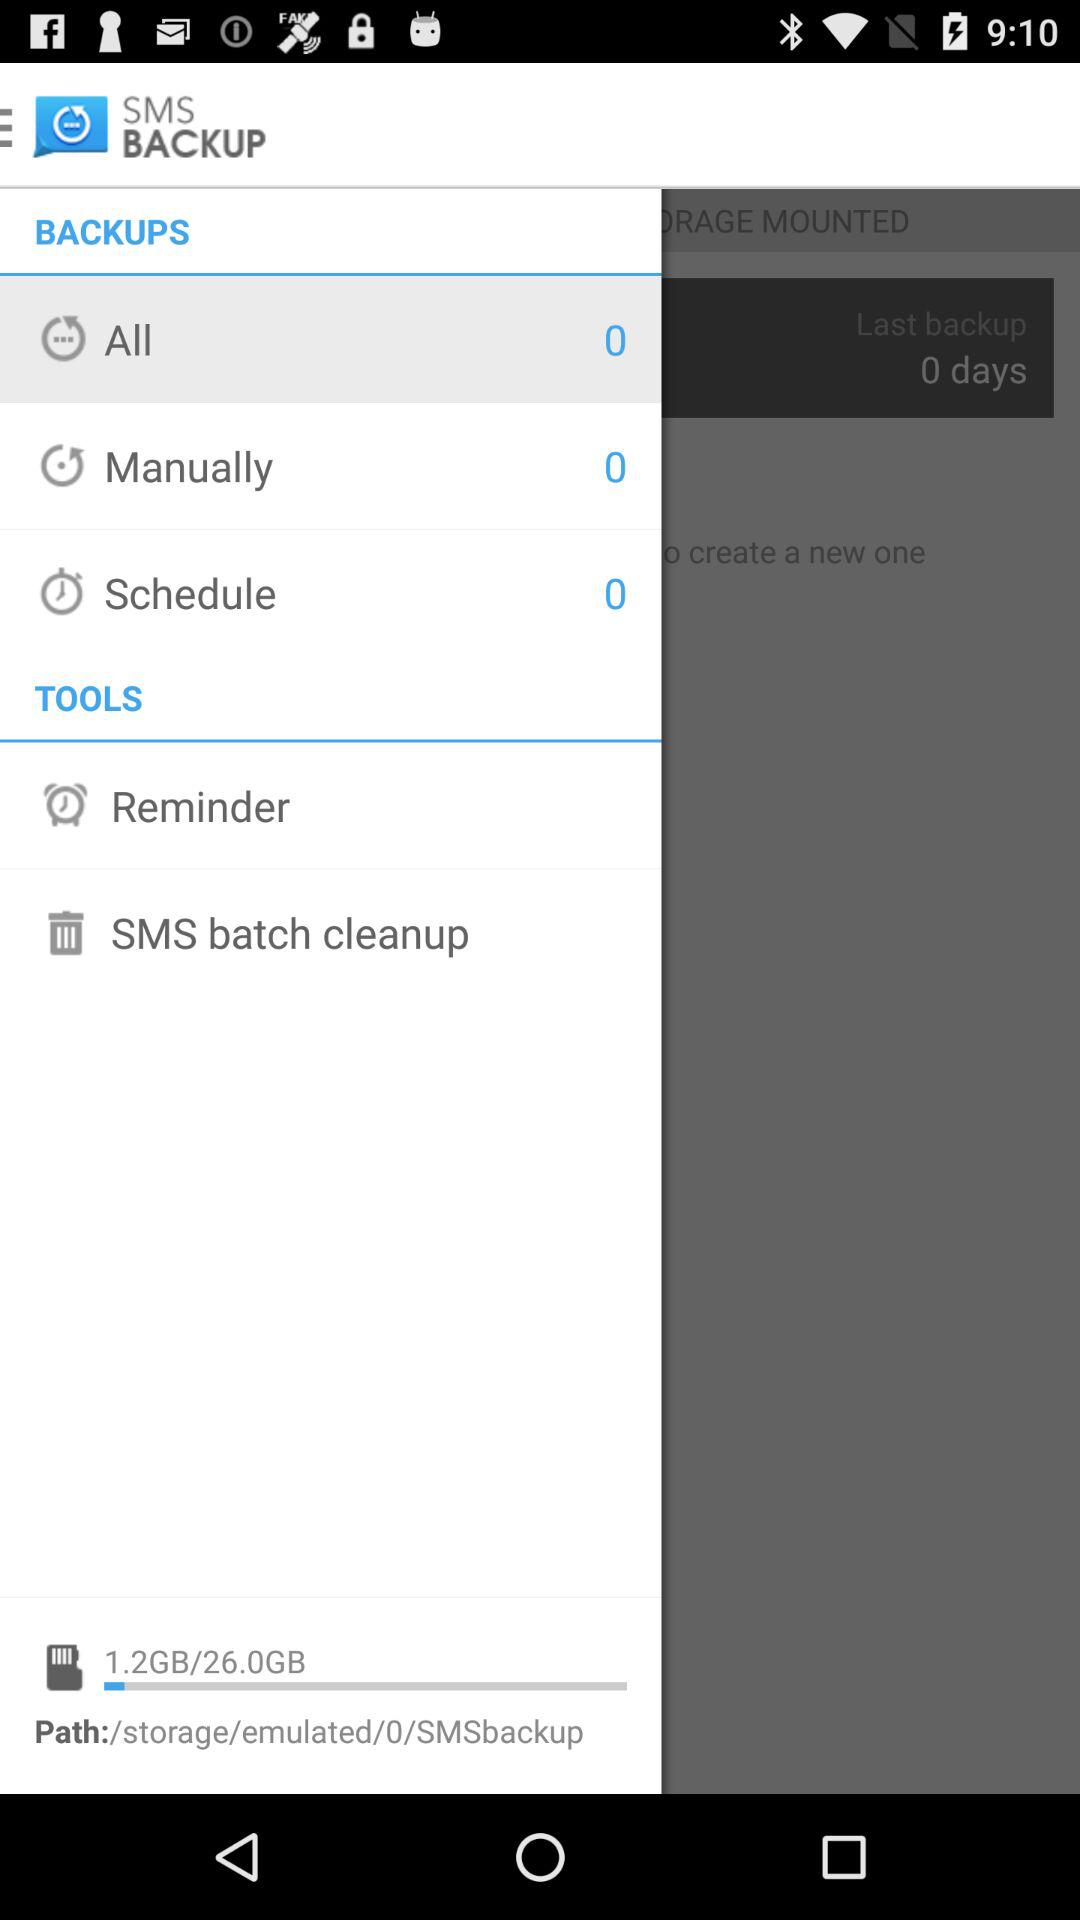What is the total storage capacity? The total storage capacity is 26.0 GB. 